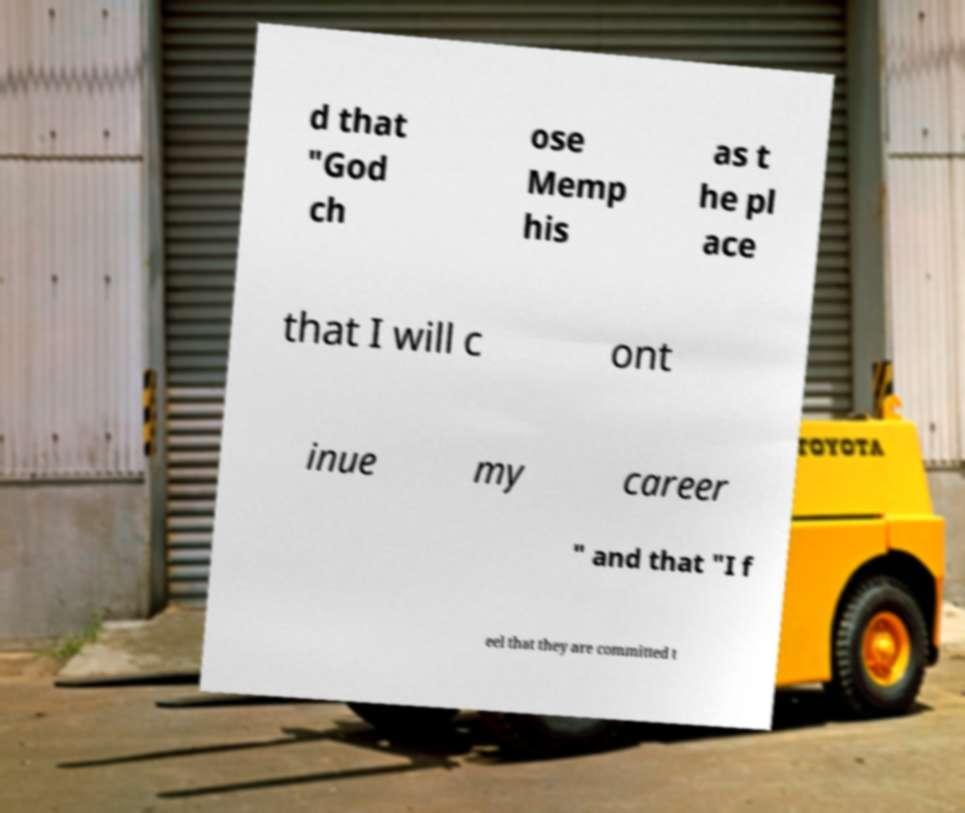Could you extract and type out the text from this image? d that "God ch ose Memp his as t he pl ace that I will c ont inue my career " and that "I f eel that they are committed t 